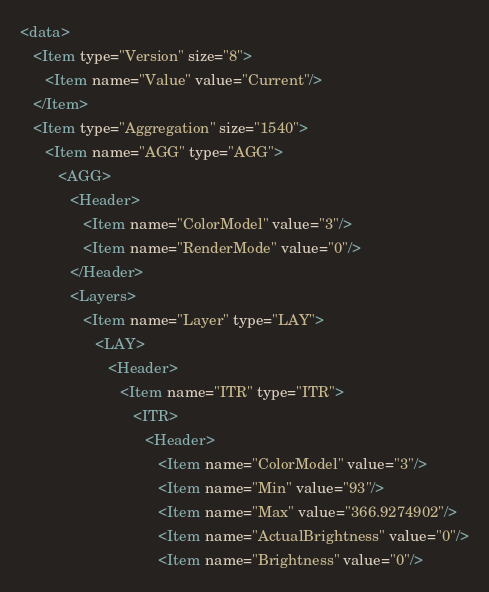Convert code to text. <code><loc_0><loc_0><loc_500><loc_500><_XML_><data>
   <Item type="Version" size="8">
      <Item name="Value" value="Current"/>
   </Item>
   <Item type="Aggregation" size="1540">
      <Item name="AGG" type="AGG">
         <AGG>
            <Header>
               <Item name="ColorModel" value="3"/>
               <Item name="RenderMode" value="0"/>
            </Header>
            <Layers>
               <Item name="Layer" type="LAY">
                  <LAY>
                     <Header>
                        <Item name="ITR" type="ITR">
                           <ITR>
                              <Header>
                                 <Item name="ColorModel" value="3"/>
                                 <Item name="Min" value="93"/>
                                 <Item name="Max" value="366.9274902"/>
                                 <Item name="ActualBrightness" value="0"/>
                                 <Item name="Brightness" value="0"/></code> 